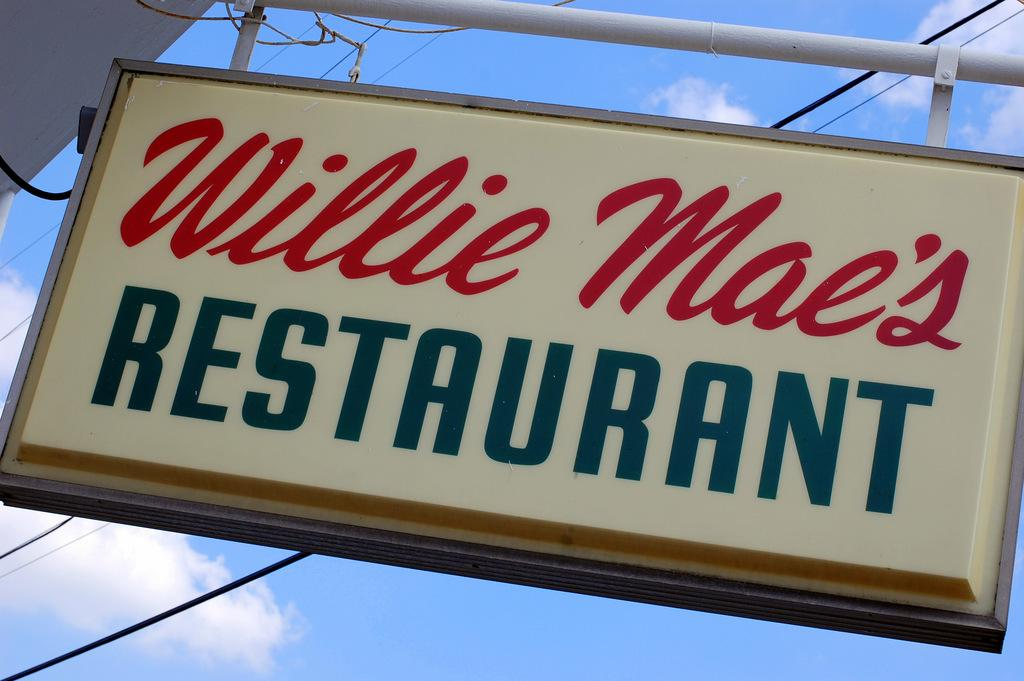<image>
Summarize the visual content of the image. Wille Mae's Restaurant's sign is displayed high on a bright day. 